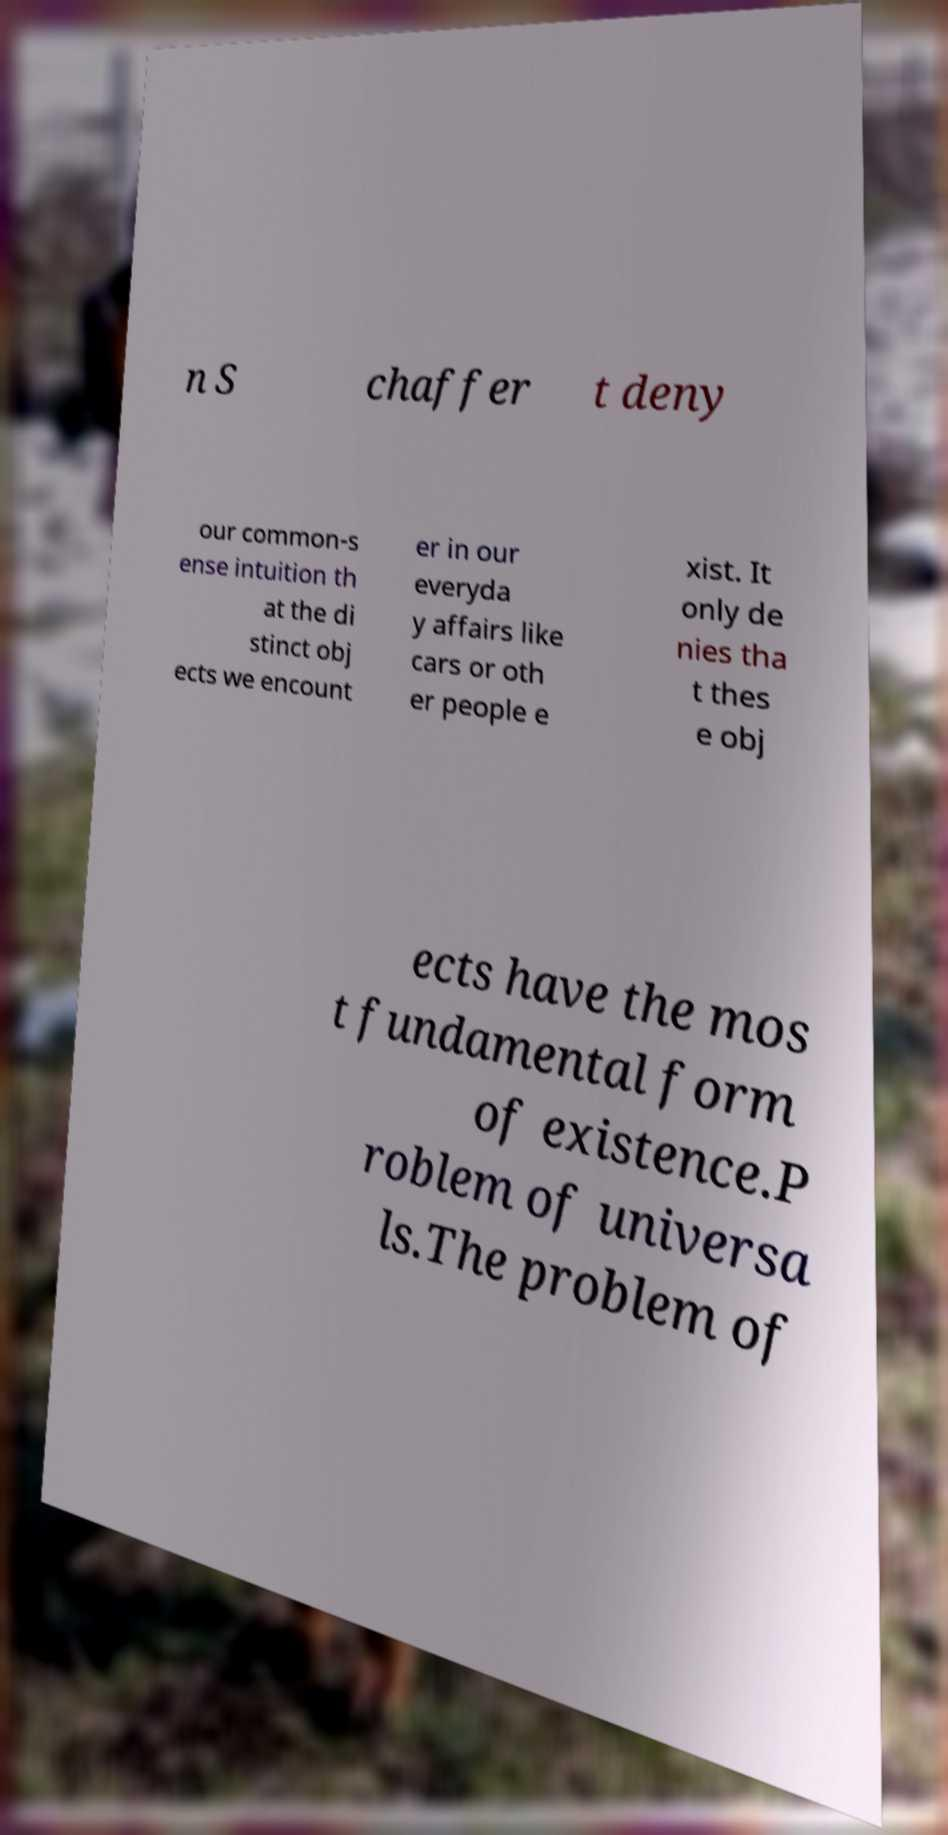Please identify and transcribe the text found in this image. n S chaffer t deny our common-s ense intuition th at the di stinct obj ects we encount er in our everyda y affairs like cars or oth er people e xist. It only de nies tha t thes e obj ects have the mos t fundamental form of existence.P roblem of universa ls.The problem of 